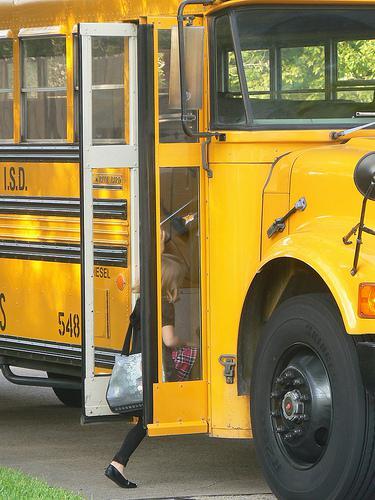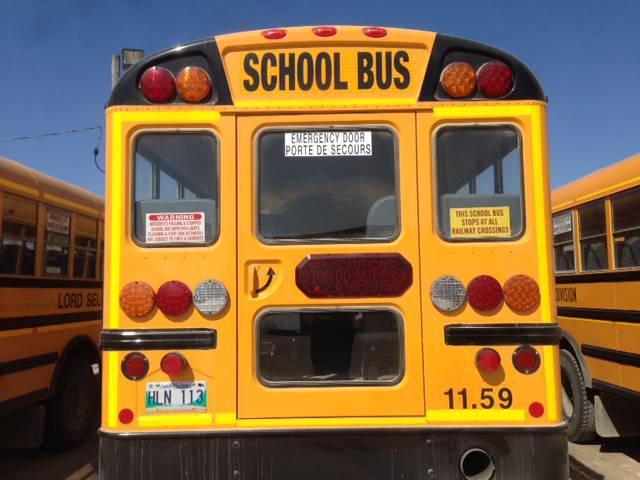The first image is the image on the left, the second image is the image on the right. Examine the images to the left and right. Is the description "One image shows schoolbuses parked next to each other facing rightward." accurate? Answer yes or no. No. The first image is the image on the left, the second image is the image on the right. For the images displayed, is the sentence "In the left image, one person is in front of the open side-entry passenger door of a bus." factually correct? Answer yes or no. Yes. 